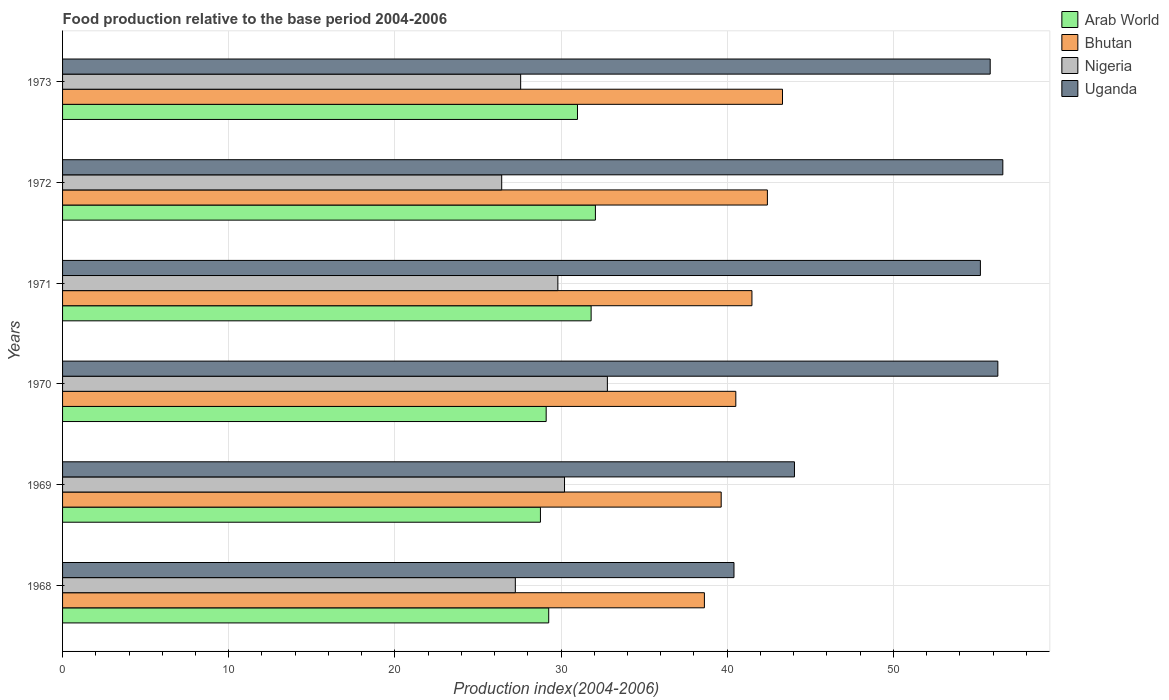Are the number of bars on each tick of the Y-axis equal?
Offer a very short reply. Yes. How many bars are there on the 3rd tick from the top?
Your answer should be very brief. 4. What is the label of the 2nd group of bars from the top?
Give a very brief answer. 1972. In how many cases, is the number of bars for a given year not equal to the number of legend labels?
Provide a short and direct response. 0. What is the food production index in Nigeria in 1971?
Make the answer very short. 29.81. Across all years, what is the maximum food production index in Arab World?
Make the answer very short. 32.07. Across all years, what is the minimum food production index in Nigeria?
Offer a terse response. 26.43. In which year was the food production index in Bhutan minimum?
Ensure brevity in your answer.  1968. What is the total food production index in Bhutan in the graph?
Keep it short and to the point. 246.03. What is the difference between the food production index in Uganda in 1971 and that in 1973?
Make the answer very short. -0.59. What is the difference between the food production index in Nigeria in 1971 and the food production index in Arab World in 1970?
Give a very brief answer. 0.7. What is the average food production index in Nigeria per year?
Keep it short and to the point. 29.01. In the year 1970, what is the difference between the food production index in Uganda and food production index in Bhutan?
Offer a terse response. 15.77. What is the ratio of the food production index in Arab World in 1971 to that in 1972?
Provide a succinct answer. 0.99. Is the food production index in Arab World in 1969 less than that in 1971?
Ensure brevity in your answer.  Yes. Is the difference between the food production index in Uganda in 1968 and 1972 greater than the difference between the food production index in Bhutan in 1968 and 1972?
Give a very brief answer. No. What is the difference between the highest and the second highest food production index in Arab World?
Provide a short and direct response. 0.26. What is the difference between the highest and the lowest food production index in Nigeria?
Ensure brevity in your answer.  6.36. In how many years, is the food production index in Uganda greater than the average food production index in Uganda taken over all years?
Provide a short and direct response. 4. What does the 1st bar from the top in 1970 represents?
Offer a terse response. Uganda. What does the 1st bar from the bottom in 1969 represents?
Keep it short and to the point. Arab World. Is it the case that in every year, the sum of the food production index in Nigeria and food production index in Arab World is greater than the food production index in Uganda?
Ensure brevity in your answer.  Yes. Are the values on the major ticks of X-axis written in scientific E-notation?
Ensure brevity in your answer.  No. Does the graph contain any zero values?
Make the answer very short. No. Does the graph contain grids?
Give a very brief answer. Yes. Where does the legend appear in the graph?
Provide a succinct answer. Top right. What is the title of the graph?
Offer a terse response. Food production relative to the base period 2004-2006. What is the label or title of the X-axis?
Ensure brevity in your answer.  Production index(2004-2006). What is the Production index(2004-2006) of Arab World in 1968?
Your response must be concise. 29.26. What is the Production index(2004-2006) in Bhutan in 1968?
Your answer should be very brief. 38.63. What is the Production index(2004-2006) in Nigeria in 1968?
Provide a short and direct response. 27.25. What is the Production index(2004-2006) of Uganda in 1968?
Provide a succinct answer. 40.41. What is the Production index(2004-2006) of Arab World in 1969?
Keep it short and to the point. 28.76. What is the Production index(2004-2006) in Bhutan in 1969?
Keep it short and to the point. 39.64. What is the Production index(2004-2006) in Nigeria in 1969?
Offer a terse response. 30.21. What is the Production index(2004-2006) of Uganda in 1969?
Your answer should be very brief. 44.05. What is the Production index(2004-2006) of Arab World in 1970?
Your response must be concise. 29.11. What is the Production index(2004-2006) of Bhutan in 1970?
Provide a short and direct response. 40.52. What is the Production index(2004-2006) of Nigeria in 1970?
Offer a terse response. 32.79. What is the Production index(2004-2006) of Uganda in 1970?
Your response must be concise. 56.29. What is the Production index(2004-2006) in Arab World in 1971?
Provide a succinct answer. 31.81. What is the Production index(2004-2006) of Bhutan in 1971?
Your answer should be very brief. 41.49. What is the Production index(2004-2006) of Nigeria in 1971?
Ensure brevity in your answer.  29.81. What is the Production index(2004-2006) of Uganda in 1971?
Offer a very short reply. 55.24. What is the Production index(2004-2006) in Arab World in 1972?
Offer a terse response. 32.07. What is the Production index(2004-2006) of Bhutan in 1972?
Keep it short and to the point. 42.42. What is the Production index(2004-2006) in Nigeria in 1972?
Give a very brief answer. 26.43. What is the Production index(2004-2006) in Uganda in 1972?
Ensure brevity in your answer.  56.59. What is the Production index(2004-2006) in Arab World in 1973?
Provide a succinct answer. 30.99. What is the Production index(2004-2006) in Bhutan in 1973?
Give a very brief answer. 43.33. What is the Production index(2004-2006) of Nigeria in 1973?
Offer a terse response. 27.57. What is the Production index(2004-2006) of Uganda in 1973?
Keep it short and to the point. 55.83. Across all years, what is the maximum Production index(2004-2006) in Arab World?
Give a very brief answer. 32.07. Across all years, what is the maximum Production index(2004-2006) in Bhutan?
Give a very brief answer. 43.33. Across all years, what is the maximum Production index(2004-2006) in Nigeria?
Keep it short and to the point. 32.79. Across all years, what is the maximum Production index(2004-2006) in Uganda?
Provide a short and direct response. 56.59. Across all years, what is the minimum Production index(2004-2006) in Arab World?
Provide a short and direct response. 28.76. Across all years, what is the minimum Production index(2004-2006) in Bhutan?
Your answer should be very brief. 38.63. Across all years, what is the minimum Production index(2004-2006) in Nigeria?
Your response must be concise. 26.43. Across all years, what is the minimum Production index(2004-2006) of Uganda?
Offer a terse response. 40.41. What is the total Production index(2004-2006) of Arab World in the graph?
Provide a succinct answer. 182. What is the total Production index(2004-2006) of Bhutan in the graph?
Ensure brevity in your answer.  246.03. What is the total Production index(2004-2006) of Nigeria in the graph?
Give a very brief answer. 174.06. What is the total Production index(2004-2006) in Uganda in the graph?
Your answer should be very brief. 308.41. What is the difference between the Production index(2004-2006) of Arab World in 1968 and that in 1969?
Your answer should be compact. 0.5. What is the difference between the Production index(2004-2006) in Bhutan in 1968 and that in 1969?
Give a very brief answer. -1.01. What is the difference between the Production index(2004-2006) of Nigeria in 1968 and that in 1969?
Your response must be concise. -2.96. What is the difference between the Production index(2004-2006) in Uganda in 1968 and that in 1969?
Provide a succinct answer. -3.64. What is the difference between the Production index(2004-2006) in Arab World in 1968 and that in 1970?
Make the answer very short. 0.15. What is the difference between the Production index(2004-2006) of Bhutan in 1968 and that in 1970?
Ensure brevity in your answer.  -1.89. What is the difference between the Production index(2004-2006) in Nigeria in 1968 and that in 1970?
Offer a very short reply. -5.54. What is the difference between the Production index(2004-2006) in Uganda in 1968 and that in 1970?
Your answer should be very brief. -15.88. What is the difference between the Production index(2004-2006) of Arab World in 1968 and that in 1971?
Ensure brevity in your answer.  -2.55. What is the difference between the Production index(2004-2006) of Bhutan in 1968 and that in 1971?
Give a very brief answer. -2.86. What is the difference between the Production index(2004-2006) of Nigeria in 1968 and that in 1971?
Your answer should be compact. -2.56. What is the difference between the Production index(2004-2006) in Uganda in 1968 and that in 1971?
Provide a short and direct response. -14.83. What is the difference between the Production index(2004-2006) of Arab World in 1968 and that in 1972?
Your answer should be compact. -2.81. What is the difference between the Production index(2004-2006) of Bhutan in 1968 and that in 1972?
Keep it short and to the point. -3.79. What is the difference between the Production index(2004-2006) of Nigeria in 1968 and that in 1972?
Your answer should be compact. 0.82. What is the difference between the Production index(2004-2006) of Uganda in 1968 and that in 1972?
Provide a short and direct response. -16.18. What is the difference between the Production index(2004-2006) of Arab World in 1968 and that in 1973?
Give a very brief answer. -1.73. What is the difference between the Production index(2004-2006) in Bhutan in 1968 and that in 1973?
Provide a succinct answer. -4.7. What is the difference between the Production index(2004-2006) in Nigeria in 1968 and that in 1973?
Your answer should be very brief. -0.32. What is the difference between the Production index(2004-2006) of Uganda in 1968 and that in 1973?
Offer a terse response. -15.42. What is the difference between the Production index(2004-2006) of Arab World in 1969 and that in 1970?
Your response must be concise. -0.35. What is the difference between the Production index(2004-2006) of Bhutan in 1969 and that in 1970?
Provide a succinct answer. -0.88. What is the difference between the Production index(2004-2006) of Nigeria in 1969 and that in 1970?
Make the answer very short. -2.58. What is the difference between the Production index(2004-2006) of Uganda in 1969 and that in 1970?
Your answer should be very brief. -12.24. What is the difference between the Production index(2004-2006) in Arab World in 1969 and that in 1971?
Make the answer very short. -3.05. What is the difference between the Production index(2004-2006) of Bhutan in 1969 and that in 1971?
Give a very brief answer. -1.85. What is the difference between the Production index(2004-2006) in Nigeria in 1969 and that in 1971?
Offer a very short reply. 0.4. What is the difference between the Production index(2004-2006) in Uganda in 1969 and that in 1971?
Provide a succinct answer. -11.19. What is the difference between the Production index(2004-2006) of Arab World in 1969 and that in 1972?
Give a very brief answer. -3.31. What is the difference between the Production index(2004-2006) in Bhutan in 1969 and that in 1972?
Offer a very short reply. -2.78. What is the difference between the Production index(2004-2006) in Nigeria in 1969 and that in 1972?
Offer a terse response. 3.78. What is the difference between the Production index(2004-2006) of Uganda in 1969 and that in 1972?
Make the answer very short. -12.54. What is the difference between the Production index(2004-2006) in Arab World in 1969 and that in 1973?
Your answer should be compact. -2.23. What is the difference between the Production index(2004-2006) in Bhutan in 1969 and that in 1973?
Offer a terse response. -3.69. What is the difference between the Production index(2004-2006) of Nigeria in 1969 and that in 1973?
Ensure brevity in your answer.  2.64. What is the difference between the Production index(2004-2006) in Uganda in 1969 and that in 1973?
Offer a very short reply. -11.78. What is the difference between the Production index(2004-2006) of Arab World in 1970 and that in 1971?
Make the answer very short. -2.71. What is the difference between the Production index(2004-2006) in Bhutan in 1970 and that in 1971?
Give a very brief answer. -0.97. What is the difference between the Production index(2004-2006) in Nigeria in 1970 and that in 1971?
Your answer should be very brief. 2.98. What is the difference between the Production index(2004-2006) in Uganda in 1970 and that in 1971?
Provide a succinct answer. 1.05. What is the difference between the Production index(2004-2006) of Arab World in 1970 and that in 1972?
Give a very brief answer. -2.96. What is the difference between the Production index(2004-2006) of Nigeria in 1970 and that in 1972?
Your response must be concise. 6.36. What is the difference between the Production index(2004-2006) of Arab World in 1970 and that in 1973?
Your answer should be compact. -1.88. What is the difference between the Production index(2004-2006) of Bhutan in 1970 and that in 1973?
Your answer should be very brief. -2.81. What is the difference between the Production index(2004-2006) of Nigeria in 1970 and that in 1973?
Keep it short and to the point. 5.22. What is the difference between the Production index(2004-2006) in Uganda in 1970 and that in 1973?
Your response must be concise. 0.46. What is the difference between the Production index(2004-2006) of Arab World in 1971 and that in 1972?
Your response must be concise. -0.26. What is the difference between the Production index(2004-2006) in Bhutan in 1971 and that in 1972?
Offer a very short reply. -0.93. What is the difference between the Production index(2004-2006) of Nigeria in 1971 and that in 1972?
Your answer should be compact. 3.38. What is the difference between the Production index(2004-2006) of Uganda in 1971 and that in 1972?
Ensure brevity in your answer.  -1.35. What is the difference between the Production index(2004-2006) of Arab World in 1971 and that in 1973?
Keep it short and to the point. 0.82. What is the difference between the Production index(2004-2006) of Bhutan in 1971 and that in 1973?
Make the answer very short. -1.84. What is the difference between the Production index(2004-2006) in Nigeria in 1971 and that in 1973?
Make the answer very short. 2.24. What is the difference between the Production index(2004-2006) of Uganda in 1971 and that in 1973?
Your response must be concise. -0.59. What is the difference between the Production index(2004-2006) in Arab World in 1972 and that in 1973?
Offer a terse response. 1.08. What is the difference between the Production index(2004-2006) of Bhutan in 1972 and that in 1973?
Your response must be concise. -0.91. What is the difference between the Production index(2004-2006) in Nigeria in 1972 and that in 1973?
Your answer should be very brief. -1.14. What is the difference between the Production index(2004-2006) in Uganda in 1972 and that in 1973?
Your response must be concise. 0.76. What is the difference between the Production index(2004-2006) in Arab World in 1968 and the Production index(2004-2006) in Bhutan in 1969?
Your answer should be compact. -10.38. What is the difference between the Production index(2004-2006) in Arab World in 1968 and the Production index(2004-2006) in Nigeria in 1969?
Keep it short and to the point. -0.95. What is the difference between the Production index(2004-2006) of Arab World in 1968 and the Production index(2004-2006) of Uganda in 1969?
Offer a terse response. -14.79. What is the difference between the Production index(2004-2006) in Bhutan in 1968 and the Production index(2004-2006) in Nigeria in 1969?
Keep it short and to the point. 8.42. What is the difference between the Production index(2004-2006) of Bhutan in 1968 and the Production index(2004-2006) of Uganda in 1969?
Make the answer very short. -5.42. What is the difference between the Production index(2004-2006) of Nigeria in 1968 and the Production index(2004-2006) of Uganda in 1969?
Provide a succinct answer. -16.8. What is the difference between the Production index(2004-2006) of Arab World in 1968 and the Production index(2004-2006) of Bhutan in 1970?
Provide a short and direct response. -11.26. What is the difference between the Production index(2004-2006) of Arab World in 1968 and the Production index(2004-2006) of Nigeria in 1970?
Offer a very short reply. -3.53. What is the difference between the Production index(2004-2006) in Arab World in 1968 and the Production index(2004-2006) in Uganda in 1970?
Your response must be concise. -27.03. What is the difference between the Production index(2004-2006) of Bhutan in 1968 and the Production index(2004-2006) of Nigeria in 1970?
Offer a very short reply. 5.84. What is the difference between the Production index(2004-2006) in Bhutan in 1968 and the Production index(2004-2006) in Uganda in 1970?
Your answer should be compact. -17.66. What is the difference between the Production index(2004-2006) of Nigeria in 1968 and the Production index(2004-2006) of Uganda in 1970?
Your answer should be very brief. -29.04. What is the difference between the Production index(2004-2006) in Arab World in 1968 and the Production index(2004-2006) in Bhutan in 1971?
Keep it short and to the point. -12.23. What is the difference between the Production index(2004-2006) of Arab World in 1968 and the Production index(2004-2006) of Nigeria in 1971?
Ensure brevity in your answer.  -0.55. What is the difference between the Production index(2004-2006) of Arab World in 1968 and the Production index(2004-2006) of Uganda in 1971?
Keep it short and to the point. -25.98. What is the difference between the Production index(2004-2006) of Bhutan in 1968 and the Production index(2004-2006) of Nigeria in 1971?
Provide a succinct answer. 8.82. What is the difference between the Production index(2004-2006) of Bhutan in 1968 and the Production index(2004-2006) of Uganda in 1971?
Your answer should be very brief. -16.61. What is the difference between the Production index(2004-2006) of Nigeria in 1968 and the Production index(2004-2006) of Uganda in 1971?
Offer a very short reply. -27.99. What is the difference between the Production index(2004-2006) in Arab World in 1968 and the Production index(2004-2006) in Bhutan in 1972?
Offer a terse response. -13.16. What is the difference between the Production index(2004-2006) of Arab World in 1968 and the Production index(2004-2006) of Nigeria in 1972?
Ensure brevity in your answer.  2.83. What is the difference between the Production index(2004-2006) of Arab World in 1968 and the Production index(2004-2006) of Uganda in 1972?
Your answer should be very brief. -27.33. What is the difference between the Production index(2004-2006) in Bhutan in 1968 and the Production index(2004-2006) in Uganda in 1972?
Offer a terse response. -17.96. What is the difference between the Production index(2004-2006) in Nigeria in 1968 and the Production index(2004-2006) in Uganda in 1972?
Offer a very short reply. -29.34. What is the difference between the Production index(2004-2006) of Arab World in 1968 and the Production index(2004-2006) of Bhutan in 1973?
Offer a very short reply. -14.07. What is the difference between the Production index(2004-2006) in Arab World in 1968 and the Production index(2004-2006) in Nigeria in 1973?
Your answer should be compact. 1.69. What is the difference between the Production index(2004-2006) in Arab World in 1968 and the Production index(2004-2006) in Uganda in 1973?
Give a very brief answer. -26.57. What is the difference between the Production index(2004-2006) in Bhutan in 1968 and the Production index(2004-2006) in Nigeria in 1973?
Provide a succinct answer. 11.06. What is the difference between the Production index(2004-2006) in Bhutan in 1968 and the Production index(2004-2006) in Uganda in 1973?
Provide a short and direct response. -17.2. What is the difference between the Production index(2004-2006) of Nigeria in 1968 and the Production index(2004-2006) of Uganda in 1973?
Your answer should be very brief. -28.58. What is the difference between the Production index(2004-2006) of Arab World in 1969 and the Production index(2004-2006) of Bhutan in 1970?
Give a very brief answer. -11.76. What is the difference between the Production index(2004-2006) of Arab World in 1969 and the Production index(2004-2006) of Nigeria in 1970?
Offer a terse response. -4.03. What is the difference between the Production index(2004-2006) in Arab World in 1969 and the Production index(2004-2006) in Uganda in 1970?
Keep it short and to the point. -27.53. What is the difference between the Production index(2004-2006) of Bhutan in 1969 and the Production index(2004-2006) of Nigeria in 1970?
Offer a terse response. 6.85. What is the difference between the Production index(2004-2006) of Bhutan in 1969 and the Production index(2004-2006) of Uganda in 1970?
Your answer should be compact. -16.65. What is the difference between the Production index(2004-2006) of Nigeria in 1969 and the Production index(2004-2006) of Uganda in 1970?
Your answer should be compact. -26.08. What is the difference between the Production index(2004-2006) of Arab World in 1969 and the Production index(2004-2006) of Bhutan in 1971?
Offer a very short reply. -12.73. What is the difference between the Production index(2004-2006) in Arab World in 1969 and the Production index(2004-2006) in Nigeria in 1971?
Your response must be concise. -1.05. What is the difference between the Production index(2004-2006) in Arab World in 1969 and the Production index(2004-2006) in Uganda in 1971?
Offer a very short reply. -26.48. What is the difference between the Production index(2004-2006) of Bhutan in 1969 and the Production index(2004-2006) of Nigeria in 1971?
Provide a succinct answer. 9.83. What is the difference between the Production index(2004-2006) in Bhutan in 1969 and the Production index(2004-2006) in Uganda in 1971?
Offer a very short reply. -15.6. What is the difference between the Production index(2004-2006) of Nigeria in 1969 and the Production index(2004-2006) of Uganda in 1971?
Your answer should be very brief. -25.03. What is the difference between the Production index(2004-2006) of Arab World in 1969 and the Production index(2004-2006) of Bhutan in 1972?
Ensure brevity in your answer.  -13.66. What is the difference between the Production index(2004-2006) of Arab World in 1969 and the Production index(2004-2006) of Nigeria in 1972?
Ensure brevity in your answer.  2.33. What is the difference between the Production index(2004-2006) in Arab World in 1969 and the Production index(2004-2006) in Uganda in 1972?
Offer a very short reply. -27.83. What is the difference between the Production index(2004-2006) of Bhutan in 1969 and the Production index(2004-2006) of Nigeria in 1972?
Provide a succinct answer. 13.21. What is the difference between the Production index(2004-2006) in Bhutan in 1969 and the Production index(2004-2006) in Uganda in 1972?
Provide a succinct answer. -16.95. What is the difference between the Production index(2004-2006) in Nigeria in 1969 and the Production index(2004-2006) in Uganda in 1972?
Your answer should be very brief. -26.38. What is the difference between the Production index(2004-2006) in Arab World in 1969 and the Production index(2004-2006) in Bhutan in 1973?
Your answer should be very brief. -14.57. What is the difference between the Production index(2004-2006) in Arab World in 1969 and the Production index(2004-2006) in Nigeria in 1973?
Your answer should be compact. 1.19. What is the difference between the Production index(2004-2006) in Arab World in 1969 and the Production index(2004-2006) in Uganda in 1973?
Offer a very short reply. -27.07. What is the difference between the Production index(2004-2006) of Bhutan in 1969 and the Production index(2004-2006) of Nigeria in 1973?
Offer a terse response. 12.07. What is the difference between the Production index(2004-2006) in Bhutan in 1969 and the Production index(2004-2006) in Uganda in 1973?
Ensure brevity in your answer.  -16.19. What is the difference between the Production index(2004-2006) of Nigeria in 1969 and the Production index(2004-2006) of Uganda in 1973?
Your answer should be very brief. -25.62. What is the difference between the Production index(2004-2006) of Arab World in 1970 and the Production index(2004-2006) of Bhutan in 1971?
Offer a very short reply. -12.38. What is the difference between the Production index(2004-2006) of Arab World in 1970 and the Production index(2004-2006) of Nigeria in 1971?
Provide a succinct answer. -0.7. What is the difference between the Production index(2004-2006) of Arab World in 1970 and the Production index(2004-2006) of Uganda in 1971?
Provide a short and direct response. -26.13. What is the difference between the Production index(2004-2006) in Bhutan in 1970 and the Production index(2004-2006) in Nigeria in 1971?
Your answer should be compact. 10.71. What is the difference between the Production index(2004-2006) in Bhutan in 1970 and the Production index(2004-2006) in Uganda in 1971?
Provide a succinct answer. -14.72. What is the difference between the Production index(2004-2006) in Nigeria in 1970 and the Production index(2004-2006) in Uganda in 1971?
Your answer should be very brief. -22.45. What is the difference between the Production index(2004-2006) in Arab World in 1970 and the Production index(2004-2006) in Bhutan in 1972?
Provide a succinct answer. -13.31. What is the difference between the Production index(2004-2006) of Arab World in 1970 and the Production index(2004-2006) of Nigeria in 1972?
Your response must be concise. 2.68. What is the difference between the Production index(2004-2006) in Arab World in 1970 and the Production index(2004-2006) in Uganda in 1972?
Ensure brevity in your answer.  -27.48. What is the difference between the Production index(2004-2006) in Bhutan in 1970 and the Production index(2004-2006) in Nigeria in 1972?
Offer a very short reply. 14.09. What is the difference between the Production index(2004-2006) of Bhutan in 1970 and the Production index(2004-2006) of Uganda in 1972?
Offer a terse response. -16.07. What is the difference between the Production index(2004-2006) in Nigeria in 1970 and the Production index(2004-2006) in Uganda in 1972?
Your answer should be very brief. -23.8. What is the difference between the Production index(2004-2006) of Arab World in 1970 and the Production index(2004-2006) of Bhutan in 1973?
Your response must be concise. -14.22. What is the difference between the Production index(2004-2006) in Arab World in 1970 and the Production index(2004-2006) in Nigeria in 1973?
Your response must be concise. 1.54. What is the difference between the Production index(2004-2006) of Arab World in 1970 and the Production index(2004-2006) of Uganda in 1973?
Keep it short and to the point. -26.72. What is the difference between the Production index(2004-2006) in Bhutan in 1970 and the Production index(2004-2006) in Nigeria in 1973?
Offer a very short reply. 12.95. What is the difference between the Production index(2004-2006) of Bhutan in 1970 and the Production index(2004-2006) of Uganda in 1973?
Your answer should be compact. -15.31. What is the difference between the Production index(2004-2006) in Nigeria in 1970 and the Production index(2004-2006) in Uganda in 1973?
Ensure brevity in your answer.  -23.04. What is the difference between the Production index(2004-2006) in Arab World in 1971 and the Production index(2004-2006) in Bhutan in 1972?
Keep it short and to the point. -10.61. What is the difference between the Production index(2004-2006) of Arab World in 1971 and the Production index(2004-2006) of Nigeria in 1972?
Make the answer very short. 5.38. What is the difference between the Production index(2004-2006) in Arab World in 1971 and the Production index(2004-2006) in Uganda in 1972?
Your response must be concise. -24.78. What is the difference between the Production index(2004-2006) in Bhutan in 1971 and the Production index(2004-2006) in Nigeria in 1972?
Ensure brevity in your answer.  15.06. What is the difference between the Production index(2004-2006) of Bhutan in 1971 and the Production index(2004-2006) of Uganda in 1972?
Your answer should be very brief. -15.1. What is the difference between the Production index(2004-2006) in Nigeria in 1971 and the Production index(2004-2006) in Uganda in 1972?
Offer a terse response. -26.78. What is the difference between the Production index(2004-2006) in Arab World in 1971 and the Production index(2004-2006) in Bhutan in 1973?
Offer a very short reply. -11.52. What is the difference between the Production index(2004-2006) in Arab World in 1971 and the Production index(2004-2006) in Nigeria in 1973?
Provide a short and direct response. 4.24. What is the difference between the Production index(2004-2006) of Arab World in 1971 and the Production index(2004-2006) of Uganda in 1973?
Provide a succinct answer. -24.02. What is the difference between the Production index(2004-2006) in Bhutan in 1971 and the Production index(2004-2006) in Nigeria in 1973?
Provide a short and direct response. 13.92. What is the difference between the Production index(2004-2006) of Bhutan in 1971 and the Production index(2004-2006) of Uganda in 1973?
Your answer should be very brief. -14.34. What is the difference between the Production index(2004-2006) in Nigeria in 1971 and the Production index(2004-2006) in Uganda in 1973?
Provide a short and direct response. -26.02. What is the difference between the Production index(2004-2006) in Arab World in 1972 and the Production index(2004-2006) in Bhutan in 1973?
Your answer should be compact. -11.26. What is the difference between the Production index(2004-2006) in Arab World in 1972 and the Production index(2004-2006) in Nigeria in 1973?
Your response must be concise. 4.5. What is the difference between the Production index(2004-2006) in Arab World in 1972 and the Production index(2004-2006) in Uganda in 1973?
Keep it short and to the point. -23.76. What is the difference between the Production index(2004-2006) in Bhutan in 1972 and the Production index(2004-2006) in Nigeria in 1973?
Give a very brief answer. 14.85. What is the difference between the Production index(2004-2006) of Bhutan in 1972 and the Production index(2004-2006) of Uganda in 1973?
Provide a short and direct response. -13.41. What is the difference between the Production index(2004-2006) of Nigeria in 1972 and the Production index(2004-2006) of Uganda in 1973?
Your answer should be very brief. -29.4. What is the average Production index(2004-2006) in Arab World per year?
Your answer should be very brief. 30.33. What is the average Production index(2004-2006) of Bhutan per year?
Offer a very short reply. 41.01. What is the average Production index(2004-2006) of Nigeria per year?
Provide a short and direct response. 29.01. What is the average Production index(2004-2006) in Uganda per year?
Your response must be concise. 51.4. In the year 1968, what is the difference between the Production index(2004-2006) of Arab World and Production index(2004-2006) of Bhutan?
Keep it short and to the point. -9.37. In the year 1968, what is the difference between the Production index(2004-2006) of Arab World and Production index(2004-2006) of Nigeria?
Provide a short and direct response. 2.01. In the year 1968, what is the difference between the Production index(2004-2006) in Arab World and Production index(2004-2006) in Uganda?
Give a very brief answer. -11.15. In the year 1968, what is the difference between the Production index(2004-2006) in Bhutan and Production index(2004-2006) in Nigeria?
Offer a terse response. 11.38. In the year 1968, what is the difference between the Production index(2004-2006) in Bhutan and Production index(2004-2006) in Uganda?
Offer a terse response. -1.78. In the year 1968, what is the difference between the Production index(2004-2006) of Nigeria and Production index(2004-2006) of Uganda?
Keep it short and to the point. -13.16. In the year 1969, what is the difference between the Production index(2004-2006) of Arab World and Production index(2004-2006) of Bhutan?
Offer a very short reply. -10.88. In the year 1969, what is the difference between the Production index(2004-2006) of Arab World and Production index(2004-2006) of Nigeria?
Give a very brief answer. -1.45. In the year 1969, what is the difference between the Production index(2004-2006) of Arab World and Production index(2004-2006) of Uganda?
Keep it short and to the point. -15.29. In the year 1969, what is the difference between the Production index(2004-2006) of Bhutan and Production index(2004-2006) of Nigeria?
Your answer should be compact. 9.43. In the year 1969, what is the difference between the Production index(2004-2006) of Bhutan and Production index(2004-2006) of Uganda?
Give a very brief answer. -4.41. In the year 1969, what is the difference between the Production index(2004-2006) of Nigeria and Production index(2004-2006) of Uganda?
Offer a terse response. -13.84. In the year 1970, what is the difference between the Production index(2004-2006) in Arab World and Production index(2004-2006) in Bhutan?
Make the answer very short. -11.41. In the year 1970, what is the difference between the Production index(2004-2006) in Arab World and Production index(2004-2006) in Nigeria?
Your response must be concise. -3.68. In the year 1970, what is the difference between the Production index(2004-2006) in Arab World and Production index(2004-2006) in Uganda?
Provide a short and direct response. -27.18. In the year 1970, what is the difference between the Production index(2004-2006) in Bhutan and Production index(2004-2006) in Nigeria?
Give a very brief answer. 7.73. In the year 1970, what is the difference between the Production index(2004-2006) of Bhutan and Production index(2004-2006) of Uganda?
Give a very brief answer. -15.77. In the year 1970, what is the difference between the Production index(2004-2006) of Nigeria and Production index(2004-2006) of Uganda?
Provide a succinct answer. -23.5. In the year 1971, what is the difference between the Production index(2004-2006) of Arab World and Production index(2004-2006) of Bhutan?
Offer a terse response. -9.68. In the year 1971, what is the difference between the Production index(2004-2006) in Arab World and Production index(2004-2006) in Nigeria?
Give a very brief answer. 2. In the year 1971, what is the difference between the Production index(2004-2006) in Arab World and Production index(2004-2006) in Uganda?
Your answer should be compact. -23.43. In the year 1971, what is the difference between the Production index(2004-2006) of Bhutan and Production index(2004-2006) of Nigeria?
Make the answer very short. 11.68. In the year 1971, what is the difference between the Production index(2004-2006) in Bhutan and Production index(2004-2006) in Uganda?
Provide a succinct answer. -13.75. In the year 1971, what is the difference between the Production index(2004-2006) of Nigeria and Production index(2004-2006) of Uganda?
Your answer should be very brief. -25.43. In the year 1972, what is the difference between the Production index(2004-2006) in Arab World and Production index(2004-2006) in Bhutan?
Your response must be concise. -10.35. In the year 1972, what is the difference between the Production index(2004-2006) in Arab World and Production index(2004-2006) in Nigeria?
Your answer should be compact. 5.64. In the year 1972, what is the difference between the Production index(2004-2006) of Arab World and Production index(2004-2006) of Uganda?
Your answer should be very brief. -24.52. In the year 1972, what is the difference between the Production index(2004-2006) of Bhutan and Production index(2004-2006) of Nigeria?
Your answer should be compact. 15.99. In the year 1972, what is the difference between the Production index(2004-2006) in Bhutan and Production index(2004-2006) in Uganda?
Your response must be concise. -14.17. In the year 1972, what is the difference between the Production index(2004-2006) of Nigeria and Production index(2004-2006) of Uganda?
Your response must be concise. -30.16. In the year 1973, what is the difference between the Production index(2004-2006) of Arab World and Production index(2004-2006) of Bhutan?
Your answer should be very brief. -12.34. In the year 1973, what is the difference between the Production index(2004-2006) in Arab World and Production index(2004-2006) in Nigeria?
Your answer should be very brief. 3.42. In the year 1973, what is the difference between the Production index(2004-2006) in Arab World and Production index(2004-2006) in Uganda?
Provide a succinct answer. -24.84. In the year 1973, what is the difference between the Production index(2004-2006) in Bhutan and Production index(2004-2006) in Nigeria?
Your answer should be compact. 15.76. In the year 1973, what is the difference between the Production index(2004-2006) of Nigeria and Production index(2004-2006) of Uganda?
Your answer should be very brief. -28.26. What is the ratio of the Production index(2004-2006) of Arab World in 1968 to that in 1969?
Your answer should be compact. 1.02. What is the ratio of the Production index(2004-2006) in Bhutan in 1968 to that in 1969?
Offer a terse response. 0.97. What is the ratio of the Production index(2004-2006) of Nigeria in 1968 to that in 1969?
Offer a very short reply. 0.9. What is the ratio of the Production index(2004-2006) of Uganda in 1968 to that in 1969?
Make the answer very short. 0.92. What is the ratio of the Production index(2004-2006) in Bhutan in 1968 to that in 1970?
Your answer should be very brief. 0.95. What is the ratio of the Production index(2004-2006) of Nigeria in 1968 to that in 1970?
Keep it short and to the point. 0.83. What is the ratio of the Production index(2004-2006) of Uganda in 1968 to that in 1970?
Provide a short and direct response. 0.72. What is the ratio of the Production index(2004-2006) in Arab World in 1968 to that in 1971?
Make the answer very short. 0.92. What is the ratio of the Production index(2004-2006) in Bhutan in 1968 to that in 1971?
Your response must be concise. 0.93. What is the ratio of the Production index(2004-2006) in Nigeria in 1968 to that in 1971?
Offer a very short reply. 0.91. What is the ratio of the Production index(2004-2006) of Uganda in 1968 to that in 1971?
Provide a succinct answer. 0.73. What is the ratio of the Production index(2004-2006) of Arab World in 1968 to that in 1972?
Make the answer very short. 0.91. What is the ratio of the Production index(2004-2006) of Bhutan in 1968 to that in 1972?
Your answer should be very brief. 0.91. What is the ratio of the Production index(2004-2006) of Nigeria in 1968 to that in 1972?
Your answer should be compact. 1.03. What is the ratio of the Production index(2004-2006) of Uganda in 1968 to that in 1972?
Provide a short and direct response. 0.71. What is the ratio of the Production index(2004-2006) of Arab World in 1968 to that in 1973?
Offer a terse response. 0.94. What is the ratio of the Production index(2004-2006) of Bhutan in 1968 to that in 1973?
Offer a very short reply. 0.89. What is the ratio of the Production index(2004-2006) of Nigeria in 1968 to that in 1973?
Ensure brevity in your answer.  0.99. What is the ratio of the Production index(2004-2006) of Uganda in 1968 to that in 1973?
Make the answer very short. 0.72. What is the ratio of the Production index(2004-2006) of Arab World in 1969 to that in 1970?
Make the answer very short. 0.99. What is the ratio of the Production index(2004-2006) of Bhutan in 1969 to that in 1970?
Your response must be concise. 0.98. What is the ratio of the Production index(2004-2006) of Nigeria in 1969 to that in 1970?
Give a very brief answer. 0.92. What is the ratio of the Production index(2004-2006) in Uganda in 1969 to that in 1970?
Offer a terse response. 0.78. What is the ratio of the Production index(2004-2006) in Arab World in 1969 to that in 1971?
Your answer should be compact. 0.9. What is the ratio of the Production index(2004-2006) of Bhutan in 1969 to that in 1971?
Offer a terse response. 0.96. What is the ratio of the Production index(2004-2006) in Nigeria in 1969 to that in 1971?
Provide a succinct answer. 1.01. What is the ratio of the Production index(2004-2006) of Uganda in 1969 to that in 1971?
Your answer should be compact. 0.8. What is the ratio of the Production index(2004-2006) in Arab World in 1969 to that in 1972?
Offer a very short reply. 0.9. What is the ratio of the Production index(2004-2006) of Bhutan in 1969 to that in 1972?
Your response must be concise. 0.93. What is the ratio of the Production index(2004-2006) of Nigeria in 1969 to that in 1972?
Your response must be concise. 1.14. What is the ratio of the Production index(2004-2006) in Uganda in 1969 to that in 1972?
Ensure brevity in your answer.  0.78. What is the ratio of the Production index(2004-2006) of Arab World in 1969 to that in 1973?
Provide a succinct answer. 0.93. What is the ratio of the Production index(2004-2006) in Bhutan in 1969 to that in 1973?
Your answer should be compact. 0.91. What is the ratio of the Production index(2004-2006) of Nigeria in 1969 to that in 1973?
Ensure brevity in your answer.  1.1. What is the ratio of the Production index(2004-2006) in Uganda in 1969 to that in 1973?
Your answer should be very brief. 0.79. What is the ratio of the Production index(2004-2006) of Arab World in 1970 to that in 1971?
Provide a succinct answer. 0.92. What is the ratio of the Production index(2004-2006) of Bhutan in 1970 to that in 1971?
Give a very brief answer. 0.98. What is the ratio of the Production index(2004-2006) of Arab World in 1970 to that in 1972?
Make the answer very short. 0.91. What is the ratio of the Production index(2004-2006) in Bhutan in 1970 to that in 1972?
Provide a short and direct response. 0.96. What is the ratio of the Production index(2004-2006) of Nigeria in 1970 to that in 1972?
Offer a terse response. 1.24. What is the ratio of the Production index(2004-2006) in Arab World in 1970 to that in 1973?
Offer a very short reply. 0.94. What is the ratio of the Production index(2004-2006) of Bhutan in 1970 to that in 1973?
Offer a terse response. 0.94. What is the ratio of the Production index(2004-2006) in Nigeria in 1970 to that in 1973?
Provide a succinct answer. 1.19. What is the ratio of the Production index(2004-2006) in Uganda in 1970 to that in 1973?
Ensure brevity in your answer.  1.01. What is the ratio of the Production index(2004-2006) of Arab World in 1971 to that in 1972?
Keep it short and to the point. 0.99. What is the ratio of the Production index(2004-2006) in Bhutan in 1971 to that in 1972?
Offer a terse response. 0.98. What is the ratio of the Production index(2004-2006) of Nigeria in 1971 to that in 1972?
Ensure brevity in your answer.  1.13. What is the ratio of the Production index(2004-2006) in Uganda in 1971 to that in 1972?
Offer a terse response. 0.98. What is the ratio of the Production index(2004-2006) in Arab World in 1971 to that in 1973?
Offer a very short reply. 1.03. What is the ratio of the Production index(2004-2006) of Bhutan in 1971 to that in 1973?
Ensure brevity in your answer.  0.96. What is the ratio of the Production index(2004-2006) in Nigeria in 1971 to that in 1973?
Offer a very short reply. 1.08. What is the ratio of the Production index(2004-2006) of Uganda in 1971 to that in 1973?
Keep it short and to the point. 0.99. What is the ratio of the Production index(2004-2006) of Arab World in 1972 to that in 1973?
Provide a succinct answer. 1.03. What is the ratio of the Production index(2004-2006) in Nigeria in 1972 to that in 1973?
Give a very brief answer. 0.96. What is the ratio of the Production index(2004-2006) in Uganda in 1972 to that in 1973?
Ensure brevity in your answer.  1.01. What is the difference between the highest and the second highest Production index(2004-2006) in Arab World?
Give a very brief answer. 0.26. What is the difference between the highest and the second highest Production index(2004-2006) of Bhutan?
Your answer should be compact. 0.91. What is the difference between the highest and the second highest Production index(2004-2006) of Nigeria?
Keep it short and to the point. 2.58. What is the difference between the highest and the second highest Production index(2004-2006) of Uganda?
Your answer should be compact. 0.3. What is the difference between the highest and the lowest Production index(2004-2006) in Arab World?
Ensure brevity in your answer.  3.31. What is the difference between the highest and the lowest Production index(2004-2006) in Bhutan?
Make the answer very short. 4.7. What is the difference between the highest and the lowest Production index(2004-2006) of Nigeria?
Make the answer very short. 6.36. What is the difference between the highest and the lowest Production index(2004-2006) in Uganda?
Provide a short and direct response. 16.18. 